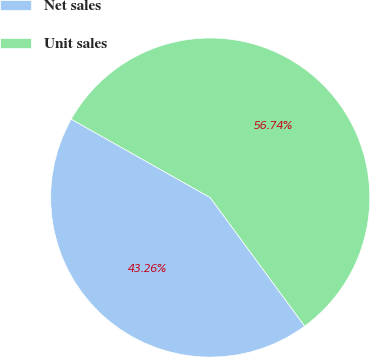<chart> <loc_0><loc_0><loc_500><loc_500><pie_chart><fcel>Net sales<fcel>Unit sales<nl><fcel>43.26%<fcel>56.74%<nl></chart> 